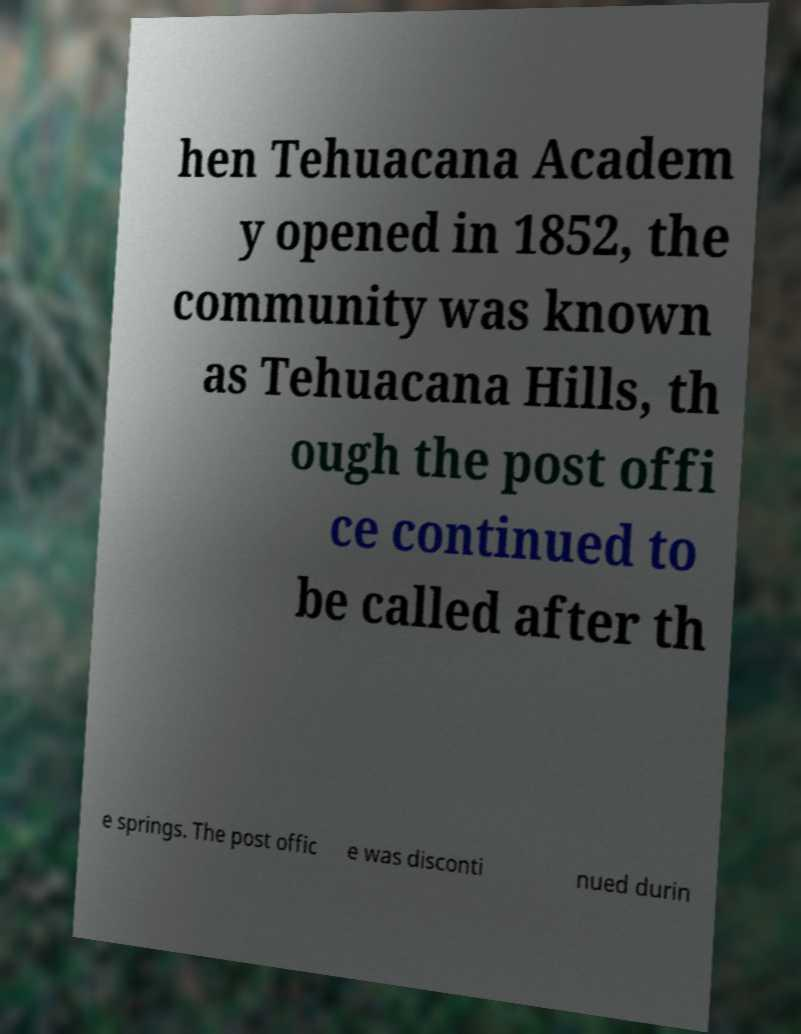For documentation purposes, I need the text within this image transcribed. Could you provide that? hen Tehuacana Academ y opened in 1852, the community was known as Tehuacana Hills, th ough the post offi ce continued to be called after th e springs. The post offic e was disconti nued durin 